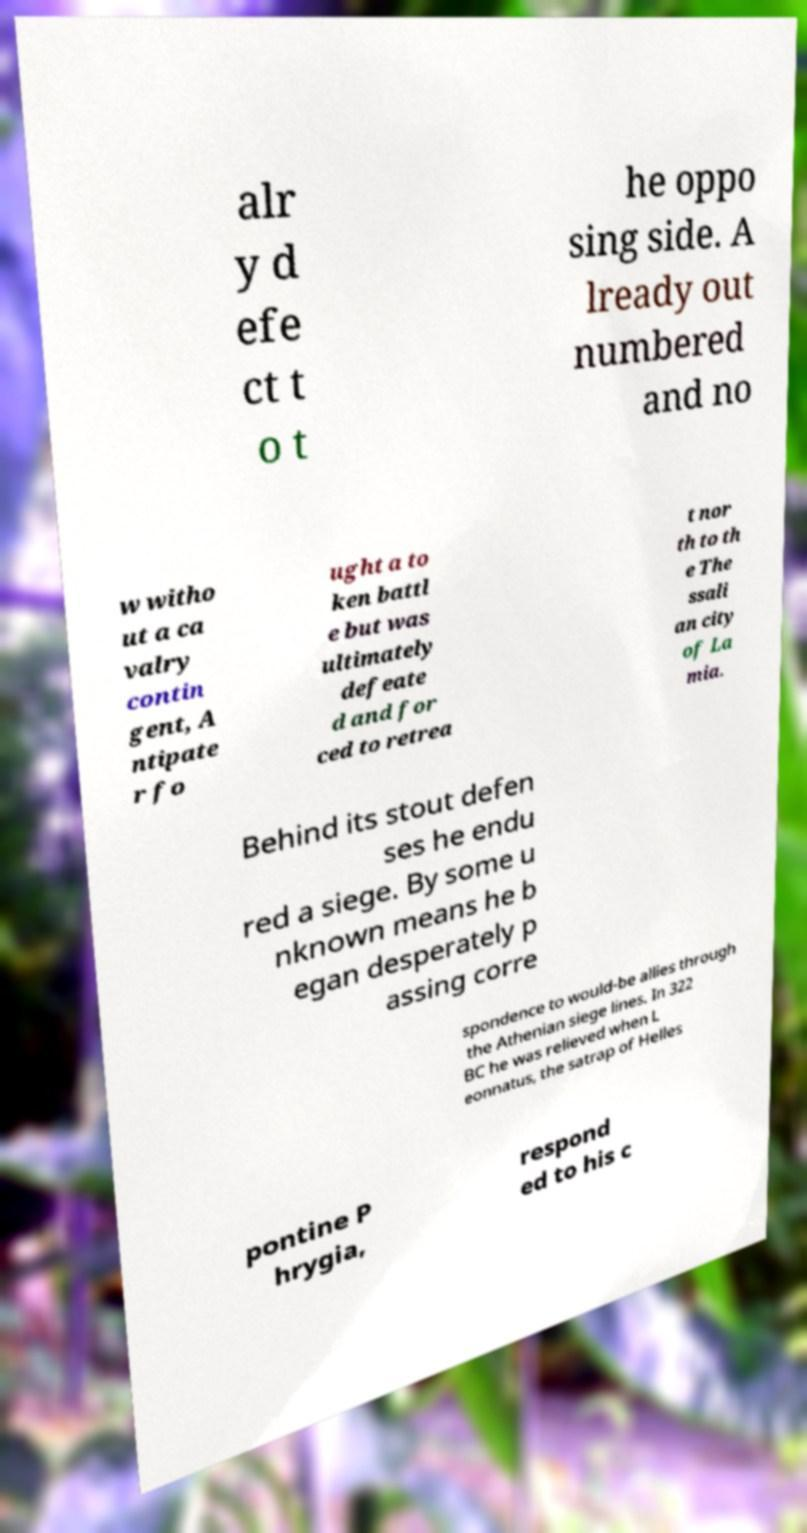There's text embedded in this image that I need extracted. Can you transcribe it verbatim? alr y d efe ct t o t he oppo sing side. A lready out numbered and no w witho ut a ca valry contin gent, A ntipate r fo ught a to ken battl e but was ultimately defeate d and for ced to retrea t nor th to th e The ssali an city of La mia. Behind its stout defen ses he endu red a siege. By some u nknown means he b egan desperately p assing corre spondence to would-be allies through the Athenian siege lines. In 322 BC he was relieved when L eonnatus, the satrap of Helles pontine P hrygia, respond ed to his c 